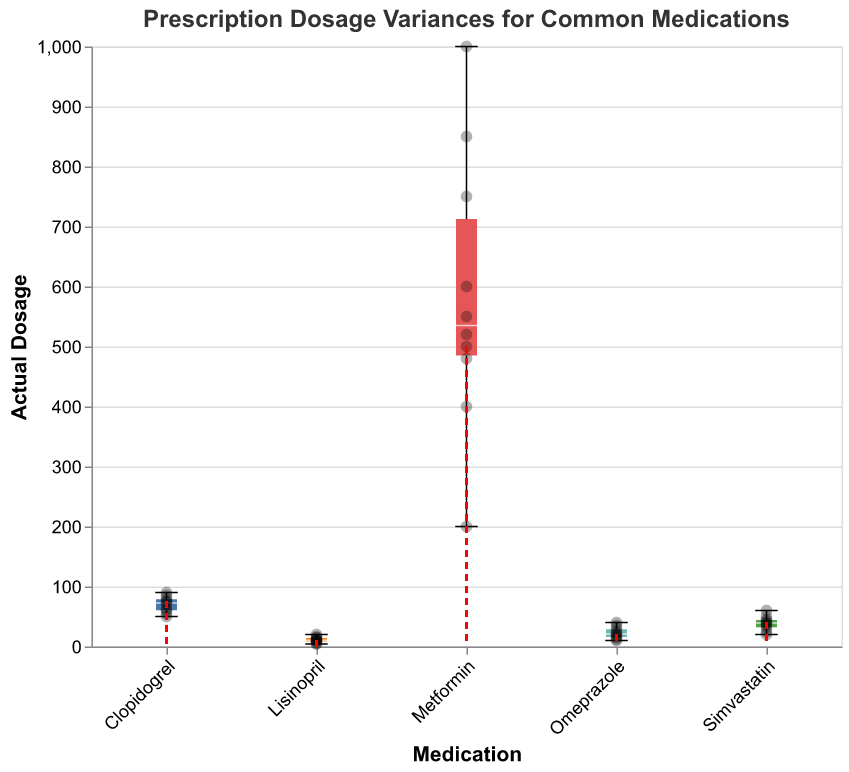What is the title of the plot? The title of the plot is displayed at the top of the figure in bold and larger font size. It reads "Prescription Dosage Variances for Common Medications."
Answer: "Prescription Dosage Variances for Common Medications" How many medications are analyzed in the plot? The x-axis lists different medications, each represented by a separate tick. There are 5 distinct medications shown: Metformin, Lisinopril, Clopidogrel, Omeprazole, and Simvastatin.
Answer: 5 What is the prescribed dosage for Metformin? The prescribed dosage is represented by a red dashed line intersecting at 500 on the y-axis for Metformin.
Answer: 500 Which medication shows the largest range in actual dosage values? The range is visible from the bottom to the top whiskers of the box plot. Metformin has the largest range, from approximately 200 to 1000.
Answer: Metformin What is the median actual dosage for Lisinopril? The median is the line within the box of the box plot. For Lisinopril, this line intersects at 10 on the y-axis.
Answer: 10 How does the variance in the actual dosage for Omeprazole compare to that for Clopidogrel? The variance can be observed by comparing the length of the whiskers of the box plots. Omeprazole has a slightly larger whisker range compared to Clopidogrel, indicating greater variance.
Answer: Omeprazole has higher variance Which medication has the most data points with actual doses at the prescribed level? By counting the overlapping black scatter points on the red dashed line, Clopidogrel has the most points at the prescribed level (75 mg).
Answer: Clopidogrel For Simvastatin, by how much does the highest actual dosage exceed the prescribed dosage? The prescribed dosage for Simvastatin is 40. The highest actual dosage, represented by the top whisker, is 60. The difference is 60 - 40 = 20.
Answer: 20 Which medication has the closest alignment between the median actual dosage and the prescribed dosage? The closest alignment can be observed where the middle line of the box plot falls very close to the red dashed line. Lisinopril’s median (10) is the same as its prescribed dosage (10), showing perfect alignment.
Answer: Lisinopril What is the range of actual dosages for Clopidogrel? The range for Clopidogrel is visible from the bottom to the top whiskers of the box plot, spanning approximately from 50 to 90.
Answer: 50 to 90 